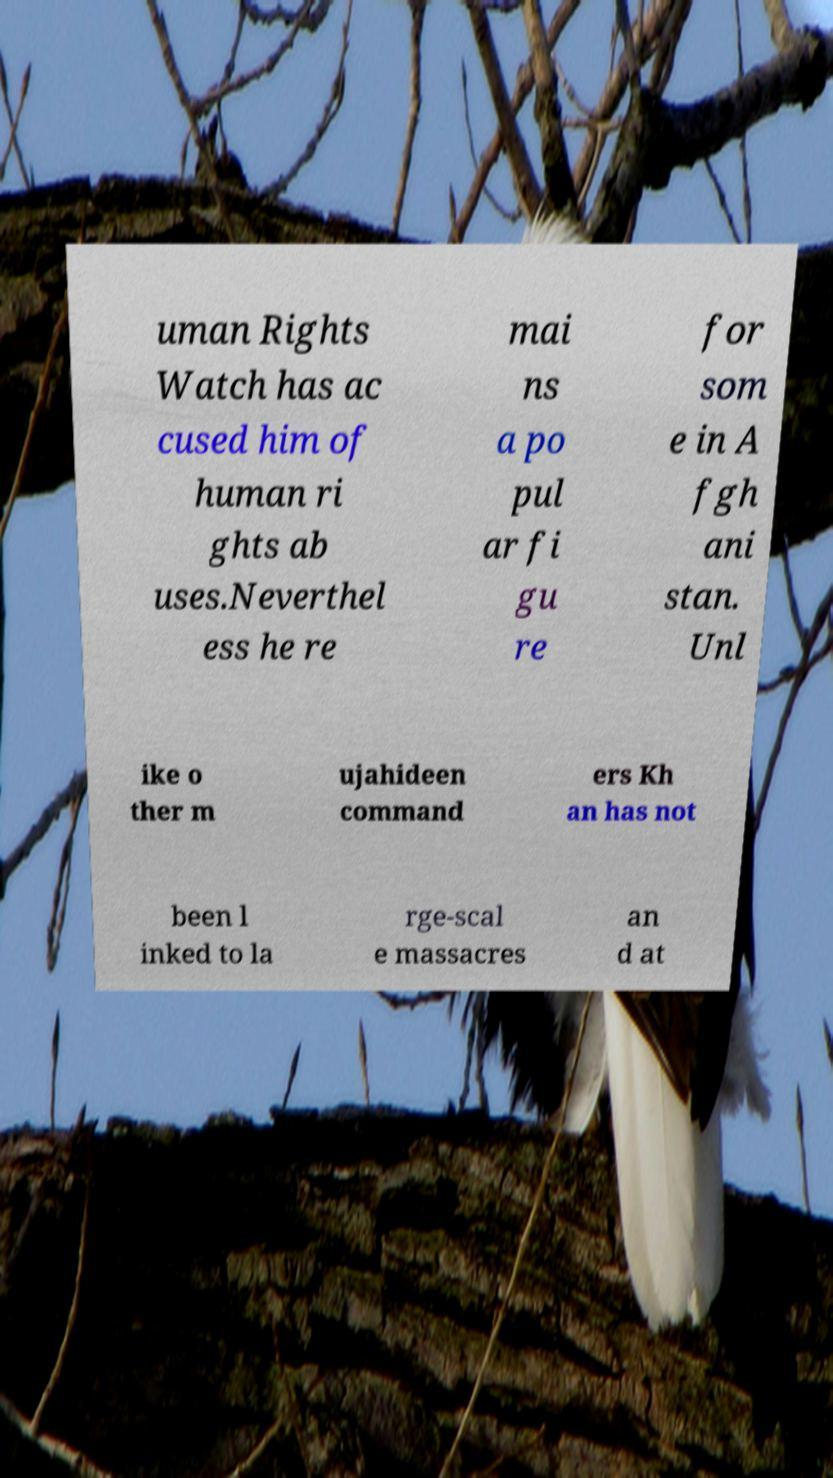Please read and relay the text visible in this image. What does it say? uman Rights Watch has ac cused him of human ri ghts ab uses.Neverthel ess he re mai ns a po pul ar fi gu re for som e in A fgh ani stan. Unl ike o ther m ujahideen command ers Kh an has not been l inked to la rge-scal e massacres an d at 